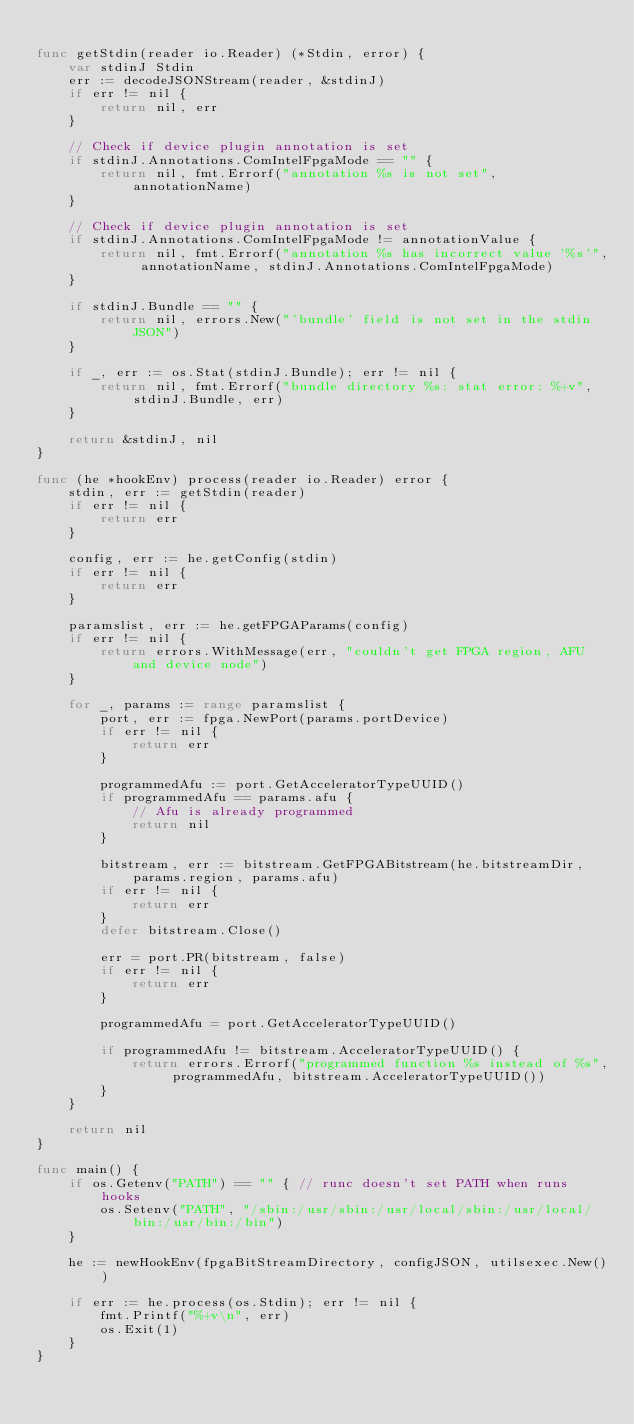Convert code to text. <code><loc_0><loc_0><loc_500><loc_500><_Go_>
func getStdin(reader io.Reader) (*Stdin, error) {
	var stdinJ Stdin
	err := decodeJSONStream(reader, &stdinJ)
	if err != nil {
		return nil, err
	}

	// Check if device plugin annotation is set
	if stdinJ.Annotations.ComIntelFpgaMode == "" {
		return nil, fmt.Errorf("annotation %s is not set", annotationName)
	}

	// Check if device plugin annotation is set
	if stdinJ.Annotations.ComIntelFpgaMode != annotationValue {
		return nil, fmt.Errorf("annotation %s has incorrect value '%s'", annotationName, stdinJ.Annotations.ComIntelFpgaMode)
	}

	if stdinJ.Bundle == "" {
		return nil, errors.New("'bundle' field is not set in the stdin JSON")
	}

	if _, err := os.Stat(stdinJ.Bundle); err != nil {
		return nil, fmt.Errorf("bundle directory %s: stat error: %+v", stdinJ.Bundle, err)
	}

	return &stdinJ, nil
}

func (he *hookEnv) process(reader io.Reader) error {
	stdin, err := getStdin(reader)
	if err != nil {
		return err
	}

	config, err := he.getConfig(stdin)
	if err != nil {
		return err
	}

	paramslist, err := he.getFPGAParams(config)
	if err != nil {
		return errors.WithMessage(err, "couldn't get FPGA region, AFU and device node")
	}

	for _, params := range paramslist {
		port, err := fpga.NewPort(params.portDevice)
		if err != nil {
			return err
		}

		programmedAfu := port.GetAcceleratorTypeUUID()
		if programmedAfu == params.afu {
			// Afu is already programmed
			return nil
		}

		bitstream, err := bitstream.GetFPGABitstream(he.bitstreamDir, params.region, params.afu)
		if err != nil {
			return err
		}
		defer bitstream.Close()

		err = port.PR(bitstream, false)
		if err != nil {
			return err
		}

		programmedAfu = port.GetAcceleratorTypeUUID()

		if programmedAfu != bitstream.AcceleratorTypeUUID() {
			return errors.Errorf("programmed function %s instead of %s", programmedAfu, bitstream.AcceleratorTypeUUID())
		}
	}

	return nil
}

func main() {
	if os.Getenv("PATH") == "" { // runc doesn't set PATH when runs hooks
		os.Setenv("PATH", "/sbin:/usr/sbin:/usr/local/sbin:/usr/local/bin:/usr/bin:/bin")
	}

	he := newHookEnv(fpgaBitStreamDirectory, configJSON, utilsexec.New())

	if err := he.process(os.Stdin); err != nil {
		fmt.Printf("%+v\n", err)
		os.Exit(1)
	}
}
</code> 